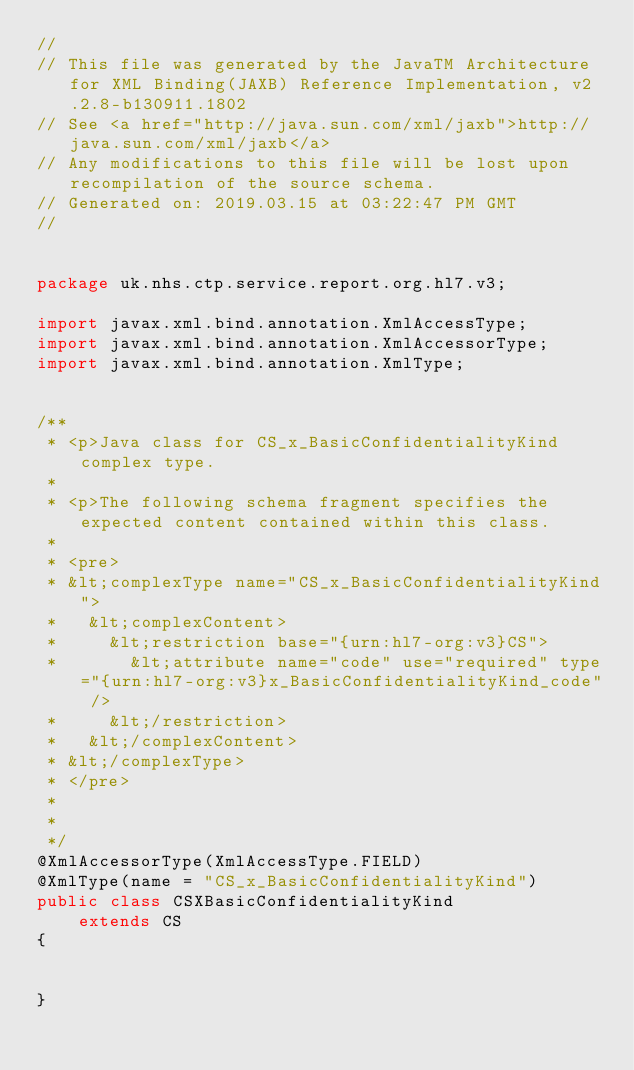<code> <loc_0><loc_0><loc_500><loc_500><_Java_>//
// This file was generated by the JavaTM Architecture for XML Binding(JAXB) Reference Implementation, v2.2.8-b130911.1802 
// See <a href="http://java.sun.com/xml/jaxb">http://java.sun.com/xml/jaxb</a> 
// Any modifications to this file will be lost upon recompilation of the source schema. 
// Generated on: 2019.03.15 at 03:22:47 PM GMT 
//


package uk.nhs.ctp.service.report.org.hl7.v3;

import javax.xml.bind.annotation.XmlAccessType;
import javax.xml.bind.annotation.XmlAccessorType;
import javax.xml.bind.annotation.XmlType;


/**
 * <p>Java class for CS_x_BasicConfidentialityKind complex type.
 * 
 * <p>The following schema fragment specifies the expected content contained within this class.
 * 
 * <pre>
 * &lt;complexType name="CS_x_BasicConfidentialityKind">
 *   &lt;complexContent>
 *     &lt;restriction base="{urn:hl7-org:v3}CS">
 *       &lt;attribute name="code" use="required" type="{urn:hl7-org:v3}x_BasicConfidentialityKind_code" />
 *     &lt;/restriction>
 *   &lt;/complexContent>
 * &lt;/complexType>
 * </pre>
 * 
 * 
 */
@XmlAccessorType(XmlAccessType.FIELD)
@XmlType(name = "CS_x_BasicConfidentialityKind")
public class CSXBasicConfidentialityKind
    extends CS
{


}
</code> 